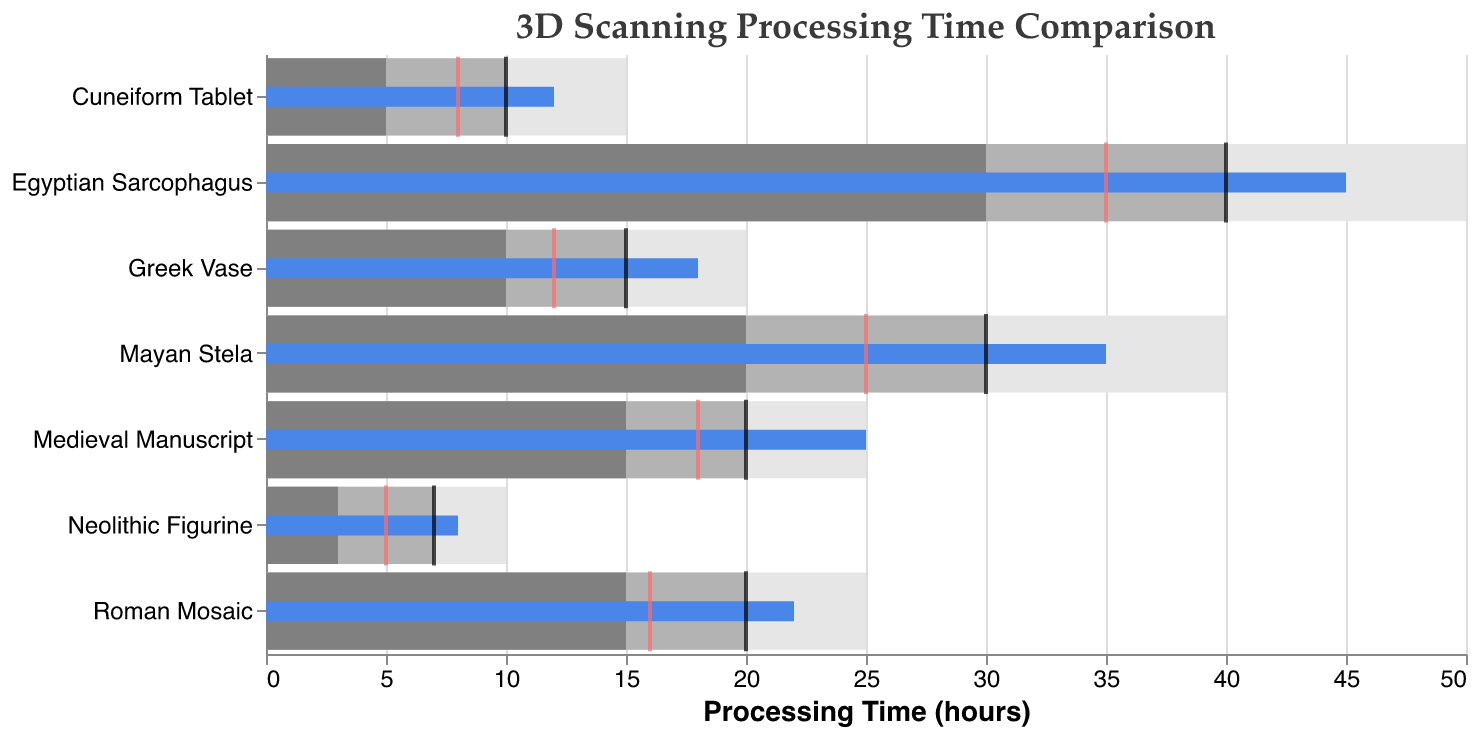What's the title of the chart? The title of the chart is displayed at the top of the figure.
Answer: 3D Scanning Processing Time Comparison Which artifact has the highest actual processing time? The actual processing time is shown by the longest blue bar. The Egyptian Sarcophagus has the highest time as its blue bar is the longest.
Answer: Egyptian Sarcophagus What is the actual processing time for the Neolithic Figurine? The actual processing time is represented by the blue bar, which for the Neolithic Figurine, ends at 8.
Answer: 8 hours Which artifact has the largest difference between its actual processing time and its target? The difference can be calculated by subtracting the target from the actual for each artifact. The differences are: 2 (Cuneiform Tablet), 3 (Greek Vase), 5 (Medieval Manuscript), 5 (Mayan Stela), 5 (Egyptian Sarcophagus), 2 (Roman Mosaic), and 1 (Neolithic Figurine). Either Medieval Manuscript, Mayan Stela, or Egyptian Sarcophagus has the largest difference, which is 5 hours.
Answer: Medieval Manuscript / Mayan Stela / Egyptian Sarcophagus Is the processing time for the Roman Mosaic within its target range? The actual processing time for the Roman Mosaic (22 hours) is compared with its target (20 hours) and the range limits (15 to 25 hours). Since 22 falls between 15 and 25, it is within the range.
Answer: Yes How many artifacts have an actual processing time that exceeds their benchmarks? The benchmark times are indicated by red ticks. Comparing each actual time (blue bars) with its benchmark, 6 artifacts (Cuneiform Tablet, Greek Vase, Medieval Manuscript, Mayan Stela, Egyptian Sarcophagus, and Roman Mosaic) exceed their benchmarks.
Answer: 6 Which artifacts have their actual processing times exactly on their target? The target times are indicated by black ticks. Comparing these with the blue bars, no artifacts have their actual processing times exactly on their targets.
Answer: None What is the total processing time for all artifacts combined? Sum the actual processing times (12, 18, 25, 35, 45, 22, 8): 12 + 18 + 25 + 35 + 45 + 22 + 8 = 165 hours.
Answer: 165 hours Between which artifacts is the range of acceptable processing times the widest? Compare range spreads (upper limit - lower limit) for each artifact: Greek Vase (10), Mayan Stela (20), Egyptian Sarcophagus (20), Roman Mosaic (10), Neolithic Figurine (7). Either Mayan Stela or Egyptian Sarcophagus has the widest spread.
Answer: Mayan Stela / Egyptian Sarcophagus What is the average benchmark processing time for the artifacts? Calculate the average of the benchmark values: (8 + 12 + 18 + 25 + 35 + 16 + 5) / 7 = 17. (129/7)
Answer: 17 hours 